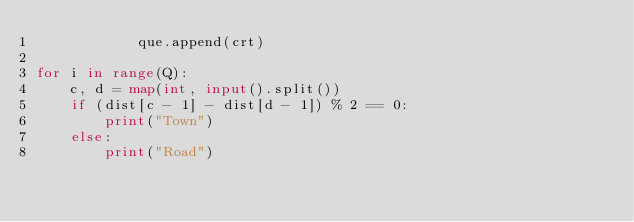Convert code to text. <code><loc_0><loc_0><loc_500><loc_500><_Python_>            que.append(crt)

for i in range(Q):
    c, d = map(int, input().split())
    if (dist[c - 1] - dist[d - 1]) % 2 == 0:
        print("Town")
    else:
        print("Road")
</code> 